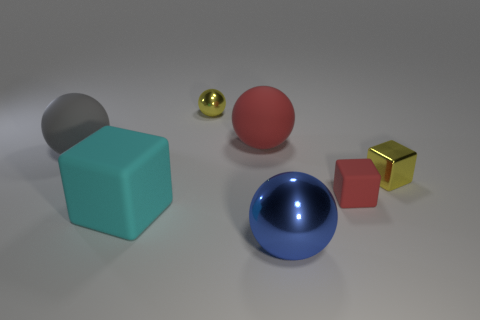What is the material of the object that is both in front of the big gray matte ball and on the left side of the large red ball?
Your response must be concise. Rubber. How many tiny matte objects are behind the shiny ball behind the small yellow cube?
Your answer should be very brief. 0. What is the shape of the blue shiny object?
Provide a succinct answer. Sphere. What is the shape of the big red object that is made of the same material as the gray object?
Make the answer very short. Sphere. There is a small yellow shiny thing left of the tiny rubber block; is it the same shape as the big red object?
Your response must be concise. Yes. What is the shape of the metallic thing that is behind the large gray thing?
Your response must be concise. Sphere. The tiny object that is the same color as the small metallic sphere is what shape?
Provide a short and direct response. Cube. How many other spheres have the same size as the gray sphere?
Your answer should be very brief. 2. What is the color of the big matte block?
Offer a terse response. Cyan. Does the tiny rubber object have the same color as the metal sphere that is behind the small rubber cube?
Your answer should be very brief. No. 